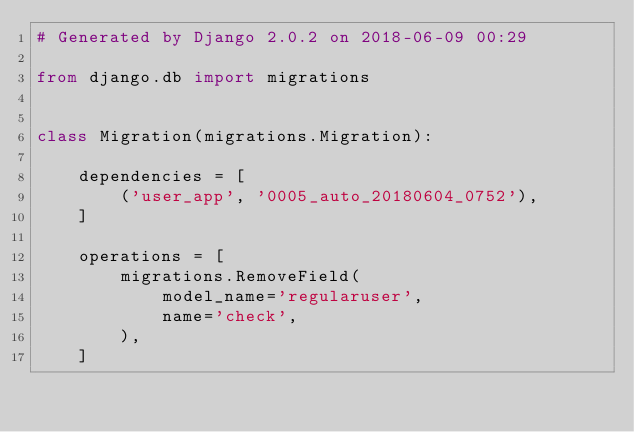Convert code to text. <code><loc_0><loc_0><loc_500><loc_500><_Python_># Generated by Django 2.0.2 on 2018-06-09 00:29

from django.db import migrations


class Migration(migrations.Migration):

    dependencies = [
        ('user_app', '0005_auto_20180604_0752'),
    ]

    operations = [
        migrations.RemoveField(
            model_name='regularuser',
            name='check',
        ),
    ]
</code> 